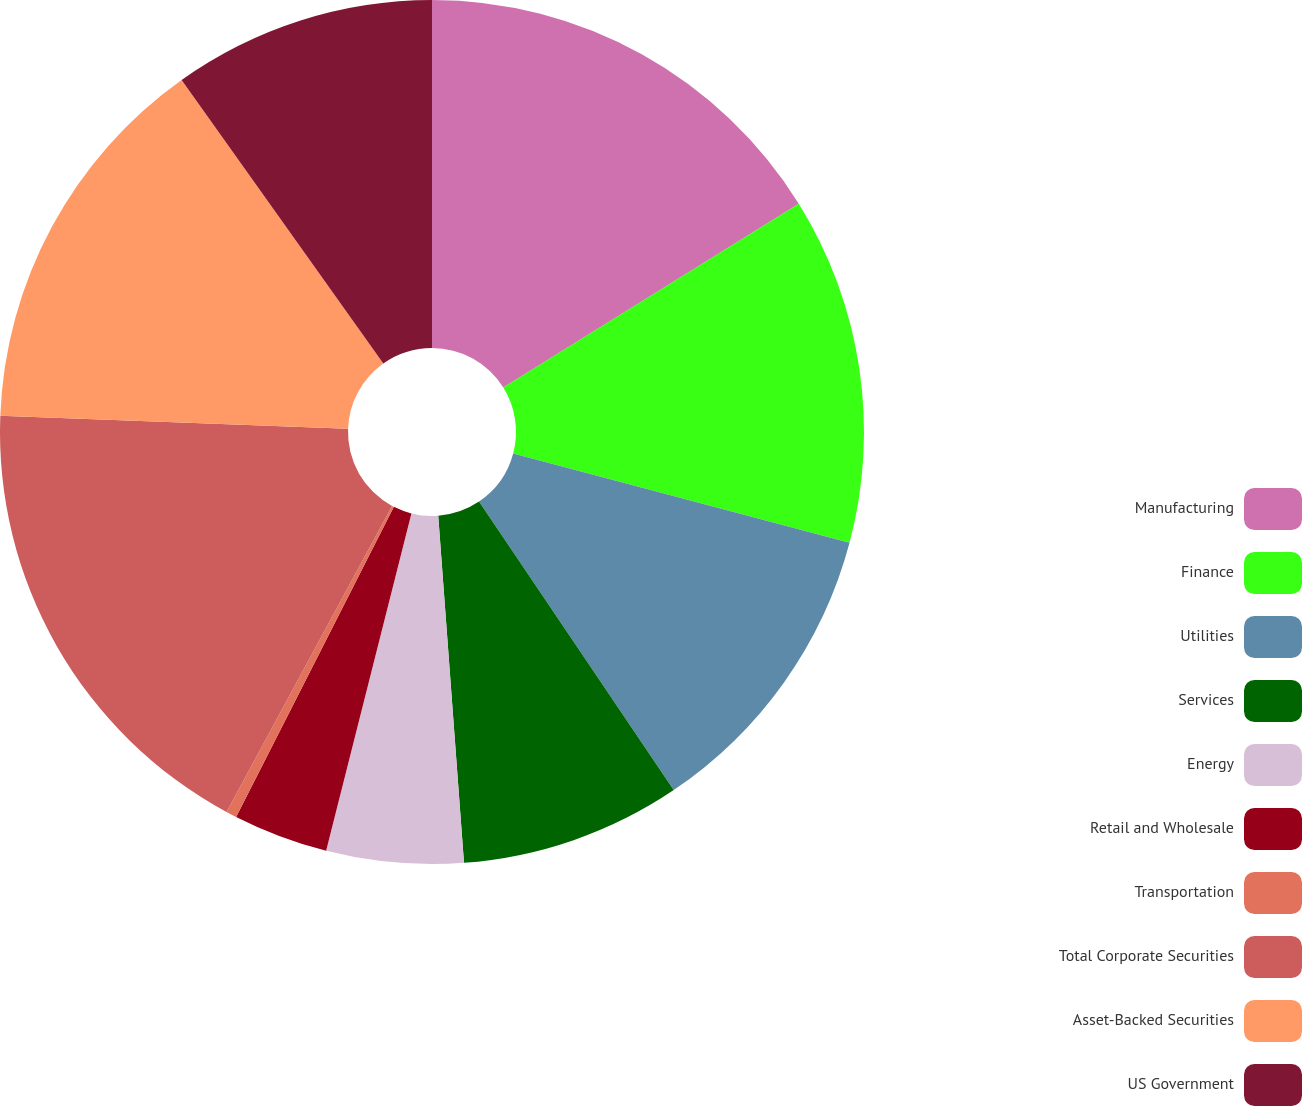<chart> <loc_0><loc_0><loc_500><loc_500><pie_chart><fcel>Manufacturing<fcel>Finance<fcel>Utilities<fcel>Services<fcel>Energy<fcel>Retail and Wholesale<fcel>Transportation<fcel>Total Corporate Securities<fcel>Asset-Backed Securities<fcel>US Government<nl><fcel>16.14%<fcel>12.99%<fcel>11.42%<fcel>8.27%<fcel>5.12%<fcel>3.55%<fcel>0.4%<fcel>17.71%<fcel>14.56%<fcel>9.84%<nl></chart> 